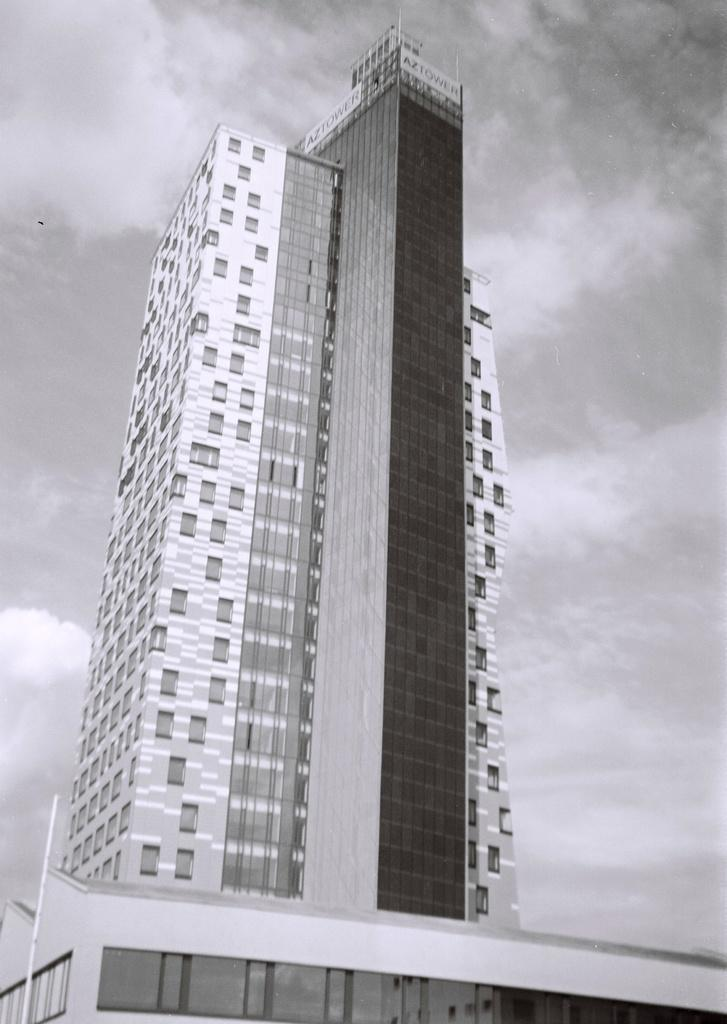What type of structures can be seen in the picture? There are buildings in the picture. What can be seen in the background of the picture? The sky is visible in the background of the picture. What is the color scheme of the picture? The picture is black and white in color. What type of mint can be seen growing on the page in the image? There is no mint or page present in the image; it features buildings and a black and white color scheme. 